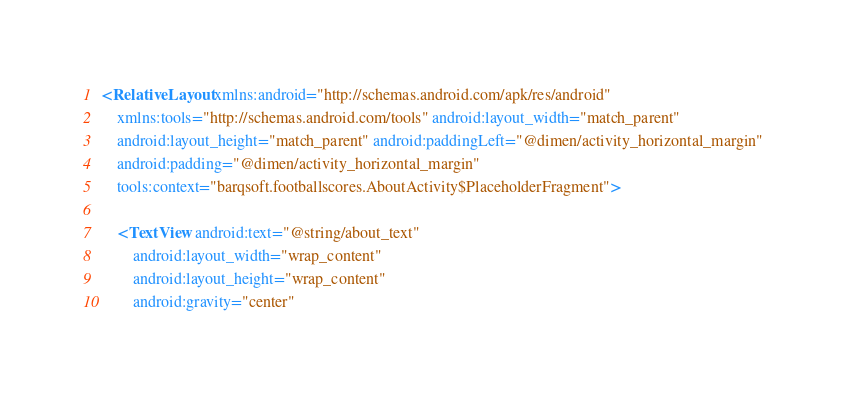<code> <loc_0><loc_0><loc_500><loc_500><_XML_><RelativeLayout xmlns:android="http://schemas.android.com/apk/res/android"
    xmlns:tools="http://schemas.android.com/tools" android:layout_width="match_parent"
    android:layout_height="match_parent" android:paddingLeft="@dimen/activity_horizontal_margin"
    android:padding="@dimen/activity_horizontal_margin"
    tools:context="barqsoft.footballscores.AboutActivity$PlaceholderFragment">

    <TextView android:text="@string/about_text"
        android:layout_width="wrap_content"
        android:layout_height="wrap_content"
        android:gravity="center"</code> 